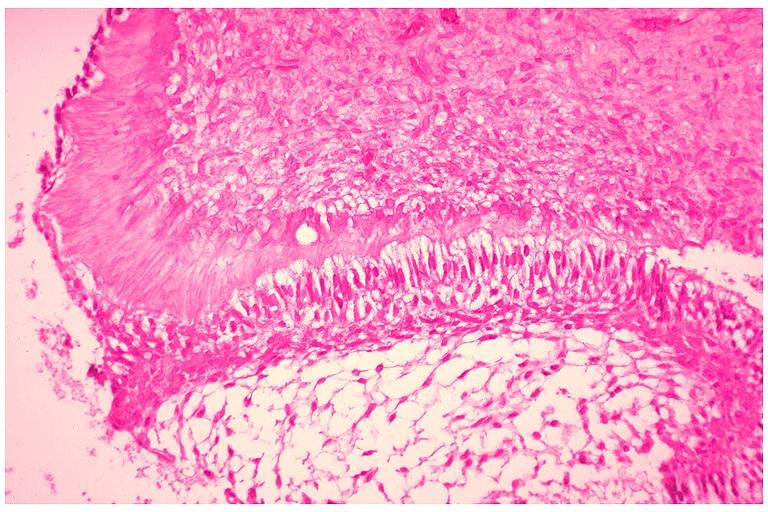what is present?
Answer the question using a single word or phrase. Oral 